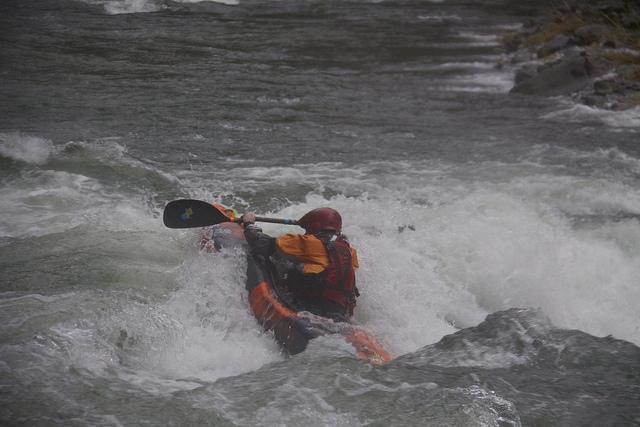How many people are sitting in kayaks?
Give a very brief answer. 1. How many adult horses are there?
Give a very brief answer. 0. 